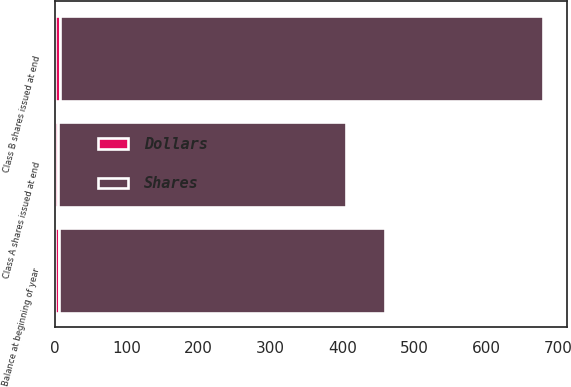Convert chart. <chart><loc_0><loc_0><loc_500><loc_500><stacked_bar_chart><ecel><fcel>Balance at beginning of year<fcel>Class A shares issued at end<fcel>Class B shares issued at end<nl><fcel>Shares<fcel>454<fcel>401<fcel>672<nl><fcel>Dollars<fcel>5<fcel>4<fcel>7<nl></chart> 